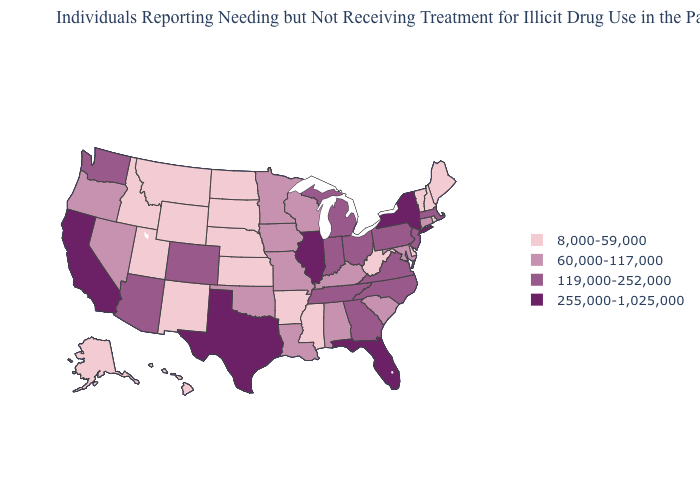What is the lowest value in the USA?
Be succinct. 8,000-59,000. Among the states that border Utah , which have the highest value?
Give a very brief answer. Arizona, Colorado. Is the legend a continuous bar?
Be succinct. No. Does Kansas have the lowest value in the MidWest?
Keep it brief. Yes. What is the value of Arkansas?
Answer briefly. 8,000-59,000. What is the lowest value in states that border Arizona?
Short answer required. 8,000-59,000. Among the states that border Kentucky , which have the lowest value?
Write a very short answer. West Virginia. What is the value of Minnesota?
Be succinct. 60,000-117,000. Which states have the highest value in the USA?
Give a very brief answer. California, Florida, Illinois, New York, Texas. What is the value of Arkansas?
Write a very short answer. 8,000-59,000. What is the value of Virginia?
Concise answer only. 119,000-252,000. How many symbols are there in the legend?
Quick response, please. 4. Does Arizona have the lowest value in the West?
Quick response, please. No. Among the states that border Illinois , does Indiana have the lowest value?
Write a very short answer. No. Among the states that border Illinois , which have the lowest value?
Short answer required. Iowa, Kentucky, Missouri, Wisconsin. 